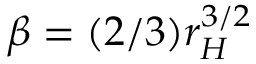Convert formula to latex. <formula><loc_0><loc_0><loc_500><loc_500>\beta = ( 2 / 3 ) r _ { H } ^ { 3 / 2 }</formula> 